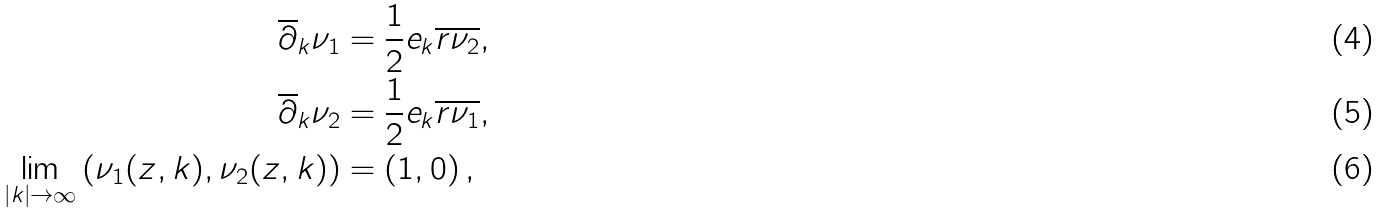<formula> <loc_0><loc_0><loc_500><loc_500>\overline { \partial } _ { k } \nu _ { 1 } & = \frac { 1 } { 2 } e _ { k } \overline { r } \overline { \nu _ { 2 } } , \\ \overline { \partial } _ { k } \nu _ { 2 } & = \frac { 1 } { 2 } e _ { k } \overline { r } \overline { \nu _ { 1 } } , \\ \lim _ { \left | k \right | \rightarrow \infty } \left ( \nu _ { 1 } ( z , k ) , \nu _ { 2 } ( z , k ) \right ) & = \left ( 1 , 0 \right ) ,</formula> 